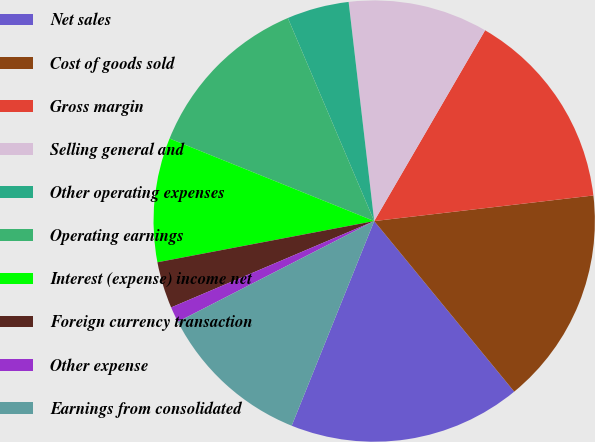Convert chart. <chart><loc_0><loc_0><loc_500><loc_500><pie_chart><fcel>Net sales<fcel>Cost of goods sold<fcel>Gross margin<fcel>Selling general and<fcel>Other operating expenses<fcel>Operating earnings<fcel>Interest (expense) income net<fcel>Foreign currency transaction<fcel>Other expense<fcel>Earnings from consolidated<nl><fcel>17.04%<fcel>15.91%<fcel>14.77%<fcel>10.23%<fcel>4.55%<fcel>12.5%<fcel>9.09%<fcel>3.41%<fcel>1.14%<fcel>11.36%<nl></chart> 